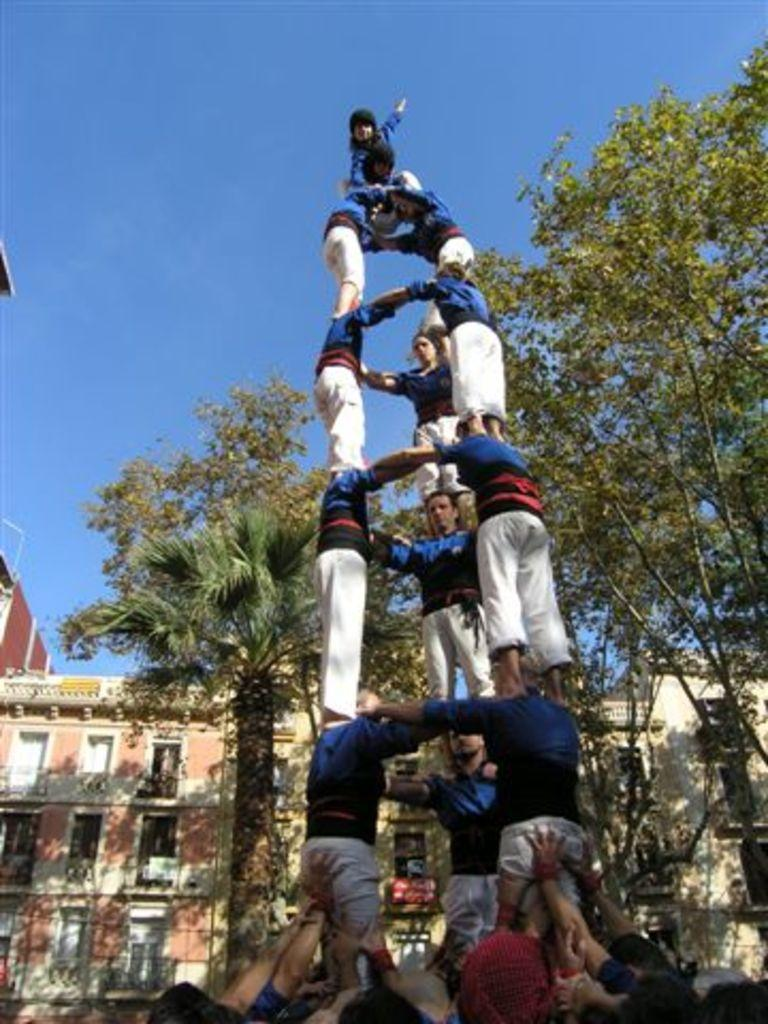Who or what can be seen in the image? There are people in the image. What type of vegetation is present in the image? There are green color trees in the image. What type of structures are visible in the image? There are buildings in the image. What is the color of the sky in the image? The sky is blue in the image. What verse can be heard recited by the dad in the image? There is no dad or verse present in the image. 